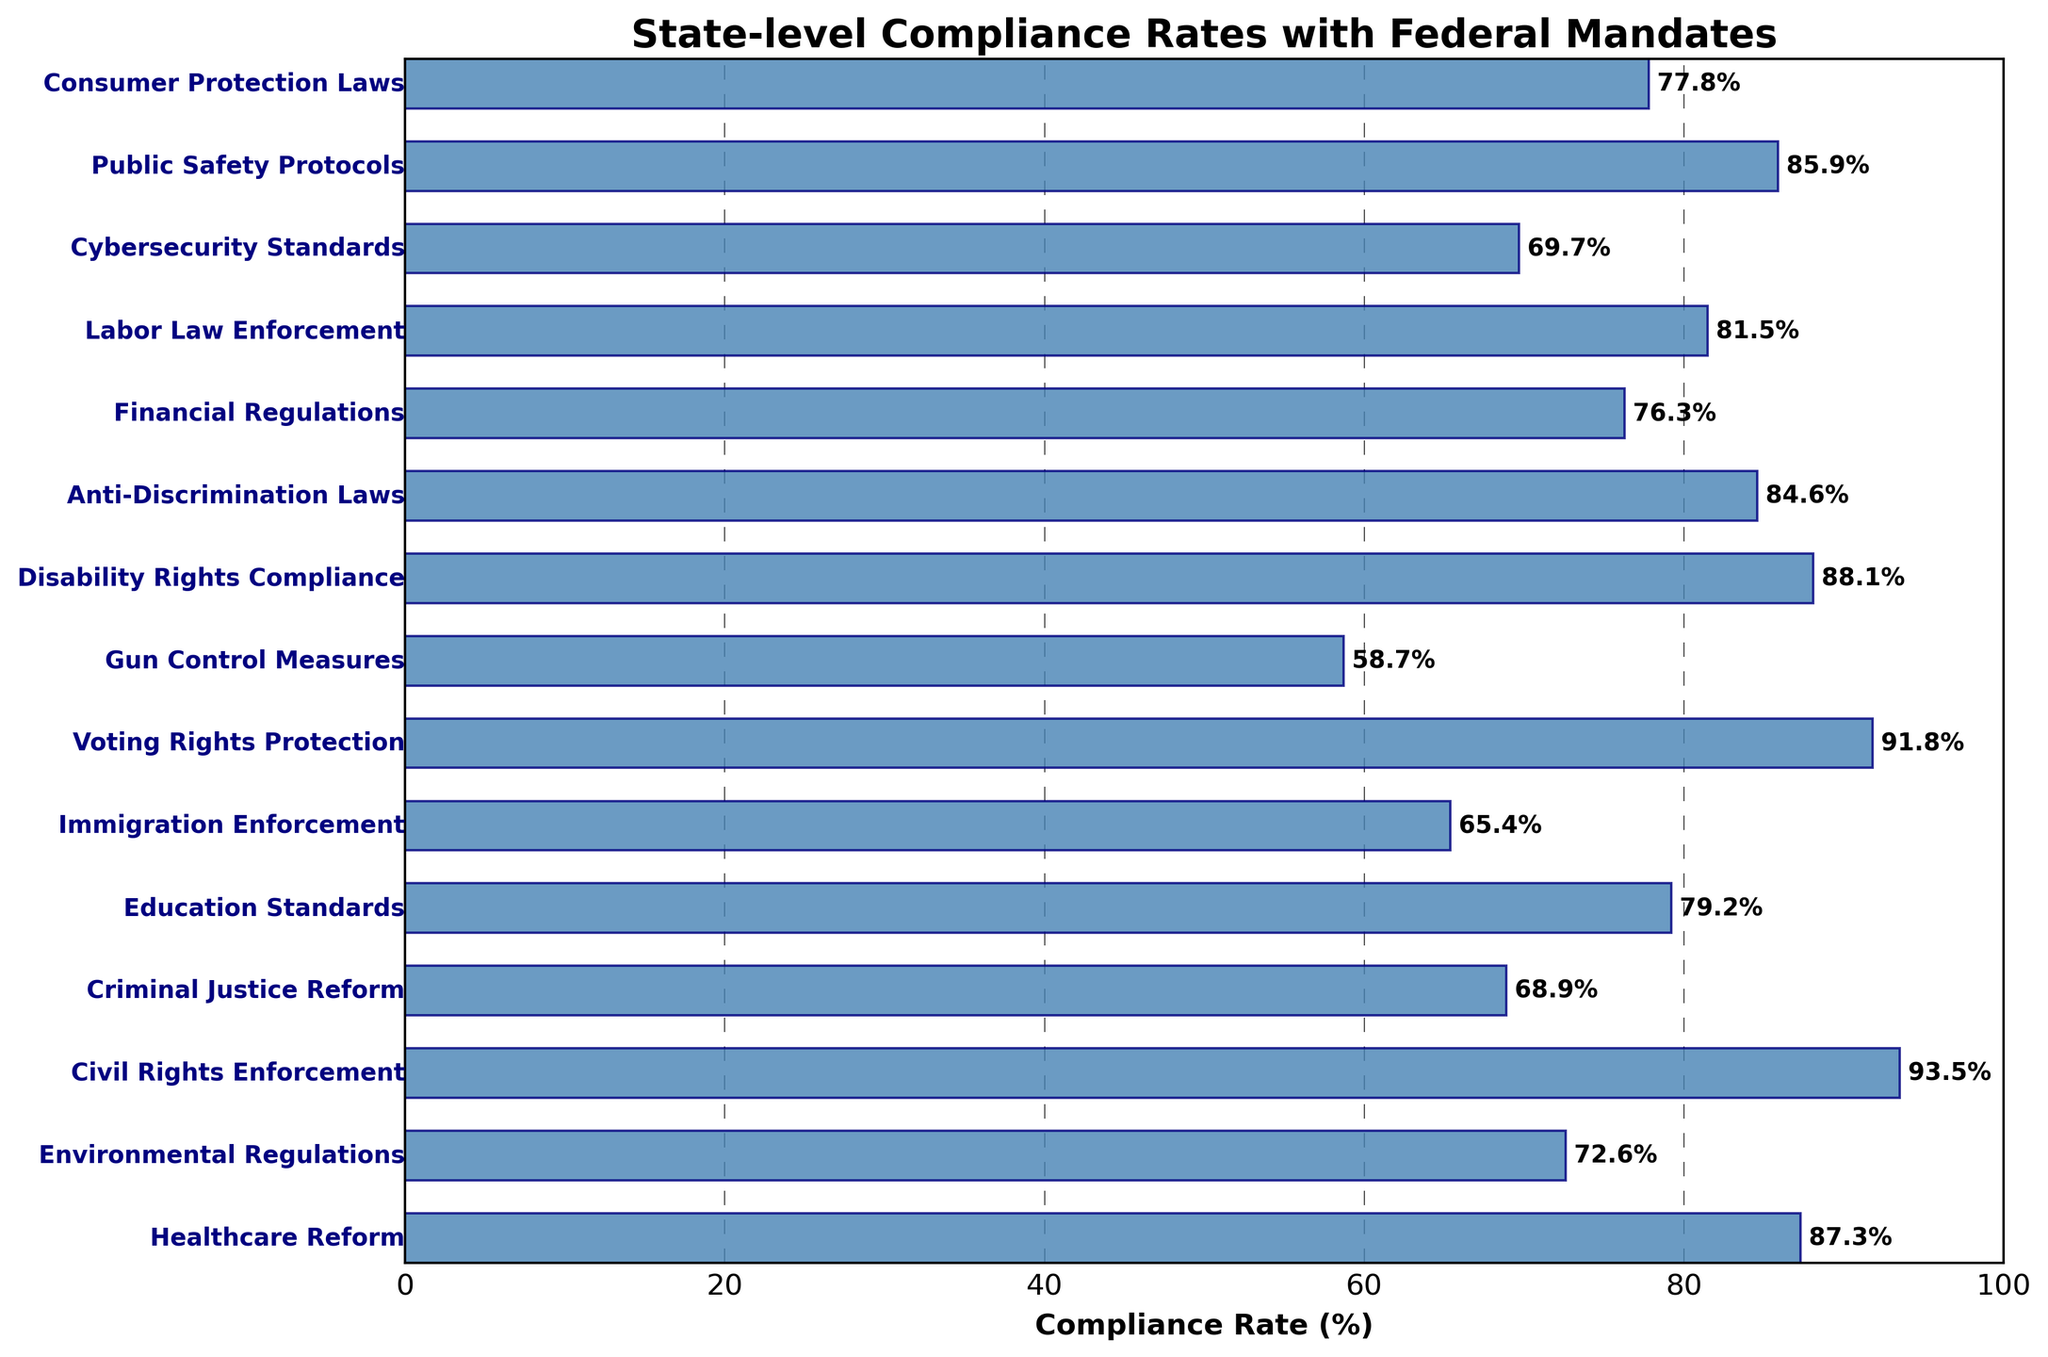What is the compliance rate for Gun Control Measures? The compliance rate for Gun Control Measures can be directly read off the respective bar representing Gun Control Measures in the figure.
Answer: 58.7% Which policy domain has the highest compliance rate? The highest compliance rate can be identified by finding the longest bar in the figure.
Answer: Civil Rights Enforcement Which policy domain has the lowest compliance rate? The lowest compliance rate can be identified by finding the shortest bar in the figure.
Answer: Gun Control Measures How much higher is the compliance rate for Healthcare Reform compared to Gun Control Measures? Find the bars for Healthcare Reform and Gun Control Measures, then subtract the compliance rate of Gun Control Measures from Healthcare Reform. (87.3 - 58.7)
Answer: 28.6% What is the average compliance rate across all policy domains? Sum all compliance rates and divide by the number of policy domains: (87.3 + 72.6 + 93.5 + 68.9 + 79.2 + 65.4 + 91.8 + 58.7 + 88.1 + 84.6 + 76.3 + 81.5 + 69.7 + 85.9 + 77.8) / 15
Answer: 78.3% How much higher is the compliance rate for Voting Rights Protection compared to Financial Regulations? Find the bars for Voting Rights Protection and Financial Regulations, then subtract the compliance rate of Financial Regulations from Voting Rights Protection. (91.8 - 76.3)
Answer: 15.5% How many policy domains have a compliance rate above 80%? Count the number of bars where the compliance rate exceeds 80%: Healthcare Reform, Civil Rights Enforcement, Voting Rights Protection, Disability Rights Compliance, Anti-Discrimination Laws, Labor Law Enforcement, and Public Safety Protocols.
Answer: 7 What is the median compliance rate across all policy domains? Sort all compliance rates and find the middle value: [58.7, 65.4, 68.9, 69.7, 72.6, 76.3, 77.8, 79.2, 81.5, 84.6, 85.9, 87.3, 88.1, 91.8, 93.5]; with 15 values, the median is the 8th value.
Answer: 79.2% 